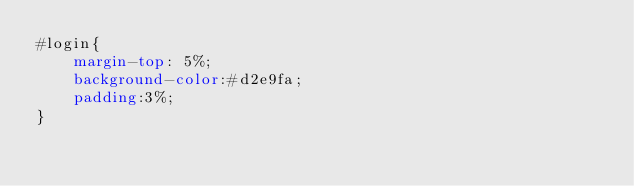Convert code to text. <code><loc_0><loc_0><loc_500><loc_500><_CSS_>#login{
    margin-top: 5%;
    background-color:#d2e9fa;
    padding:3%;
}</code> 